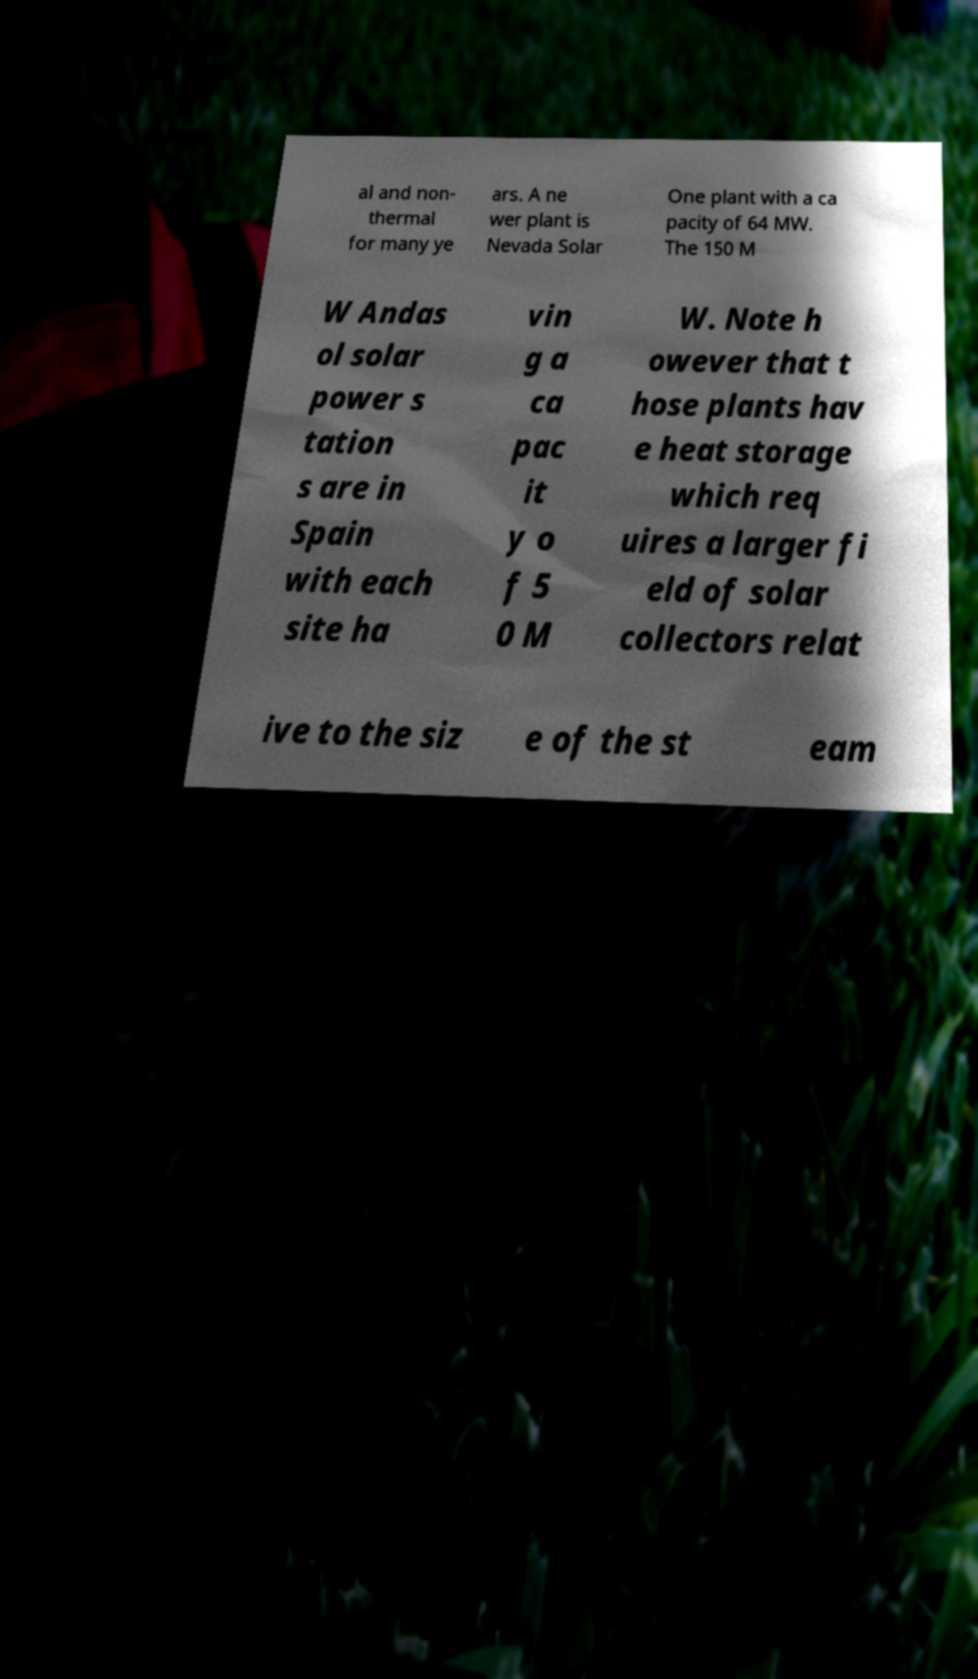There's text embedded in this image that I need extracted. Can you transcribe it verbatim? al and non- thermal for many ye ars. A ne wer plant is Nevada Solar One plant with a ca pacity of 64 MW. The 150 M W Andas ol solar power s tation s are in Spain with each site ha vin g a ca pac it y o f 5 0 M W. Note h owever that t hose plants hav e heat storage which req uires a larger fi eld of solar collectors relat ive to the siz e of the st eam 